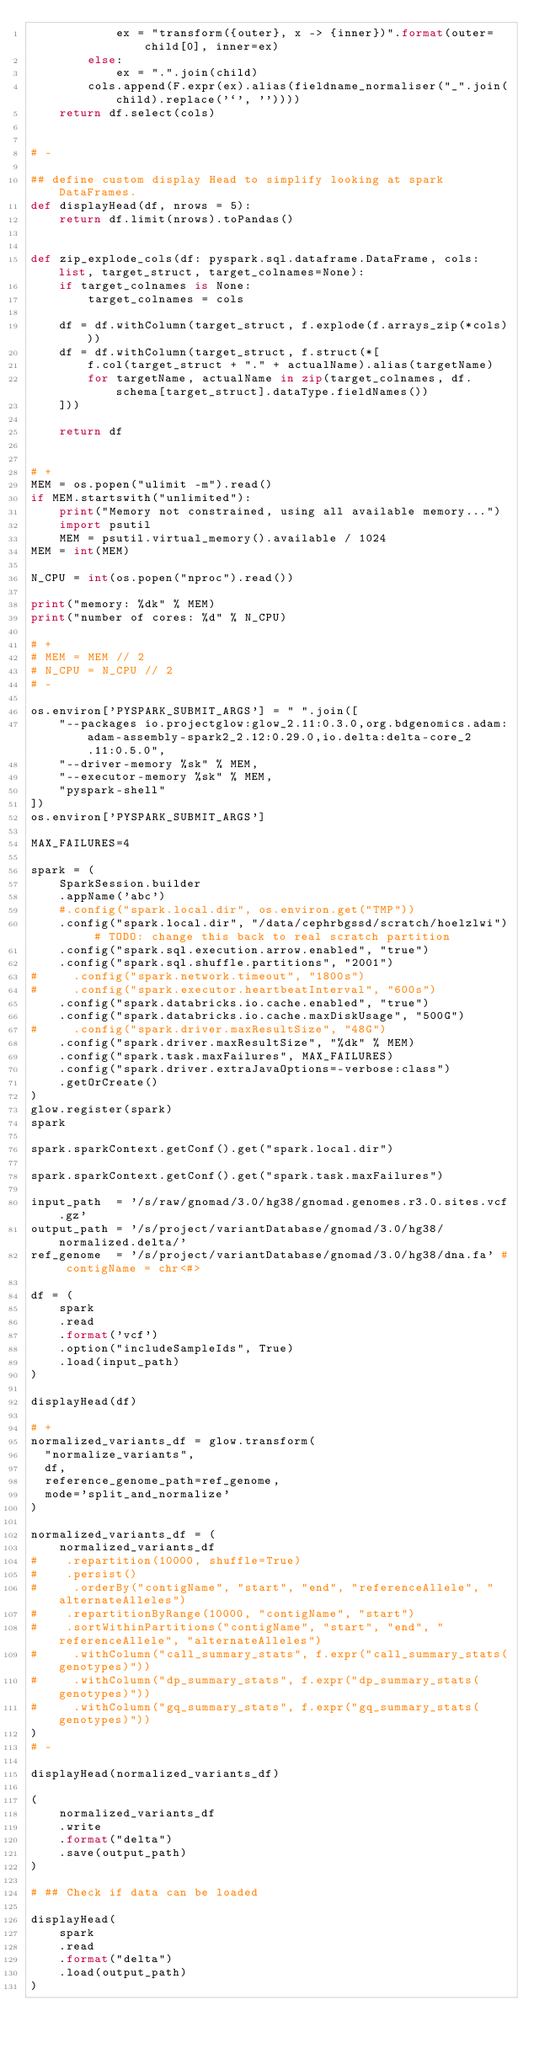Convert code to text. <code><loc_0><loc_0><loc_500><loc_500><_Python_>			ex = "transform({outer}, x -> {inner})".format(outer=child[0], inner=ex)
		else:
			ex = ".".join(child)
		cols.append(F.expr(ex).alias(fieldname_normaliser("_".join(child).replace('`', ''))))
	return df.select(cols)


# -

## define custom display Head to simplify looking at spark DataFrames.
def displayHead(df, nrows = 5):
    return df.limit(nrows).toPandas()


def zip_explode_cols(df: pyspark.sql.dataframe.DataFrame, cols: list, target_struct, target_colnames=None):
    if target_colnames is None:
        target_colnames = cols
    
    df = df.withColumn(target_struct, f.explode(f.arrays_zip(*cols)))
    df = df.withColumn(target_struct, f.struct(*[
        f.col(target_struct + "." + actualName).alias(targetName) 
        for targetName, actualName in zip(target_colnames, df.schema[target_struct].dataType.fieldNames())
    ]))
    
    return df


# +
MEM = os.popen("ulimit -m").read()
if MEM.startswith("unlimited"):
    print("Memory not constrained, using all available memory...")
    import psutil
    MEM = psutil.virtual_memory().available / 1024
MEM = int(MEM)

N_CPU = int(os.popen("nproc").read())

print("memory: %dk" % MEM)
print("number of cores: %d" % N_CPU)

# +
# MEM = MEM // 2
# N_CPU = N_CPU // 2
# -

os.environ['PYSPARK_SUBMIT_ARGS'] = " ".join([
    "--packages io.projectglow:glow_2.11:0.3.0,org.bdgenomics.adam:adam-assembly-spark2_2.12:0.29.0,io.delta:delta-core_2.11:0.5.0",
    "--driver-memory %sk" % MEM,
    "--executor-memory %sk" % MEM,
    "pyspark-shell"
])
os.environ['PYSPARK_SUBMIT_ARGS']

MAX_FAILURES=4

spark = (
    SparkSession.builder
    .appName('abc')
    #.config("spark.local.dir", os.environ.get("TMP"))
    .config("spark.local.dir", "/data/cephrbgssd/scratch/hoelzlwi") # TODO: change this back to real scratch partition
    .config("spark.sql.execution.arrow.enabled", "true")
    .config("spark.sql.shuffle.partitions", "2001")
#     .config("spark.network.timeout", "1800s")
#     .config("spark.executor.heartbeatInterval", "600s")
    .config("spark.databricks.io.cache.enabled", "true")
    .config("spark.databricks.io.cache.maxDiskUsage", "500G")
#     .config("spark.driver.maxResultSize", "48G")
    .config("spark.driver.maxResultSize", "%dk" % MEM)
    .config("spark.task.maxFailures", MAX_FAILURES)
    .config("spark.driver.extraJavaOptions=-verbose:class")
    .getOrCreate()
)
glow.register(spark)
spark

spark.sparkContext.getConf().get("spark.local.dir")

spark.sparkContext.getConf().get("spark.task.maxFailures")

input_path  = '/s/raw/gnomad/3.0/hg38/gnomad.genomes.r3.0.sites.vcf.gz'
output_path = '/s/project/variantDatabase/gnomad/3.0/hg38/normalized.delta/'
ref_genome  = '/s/project/variantDatabase/gnomad/3.0/hg38/dna.fa' # contigName = chr<#>

df = (
    spark
    .read
    .format('vcf')
    .option("includeSampleIds", True)
    .load(input_path)
)

displayHead(df)

# +
normalized_variants_df = glow.transform(
  "normalize_variants",
  df,
  reference_genome_path=ref_genome,
  mode='split_and_normalize'
)

normalized_variants_df = (
    normalized_variants_df
#    .repartition(10000, shuffle=True)
#    .persist()
#     .orderBy("contigName", "start", "end", "referenceAllele", "alternateAlleles")
#    .repartitionByRange(10000, "contigName", "start")
#    .sortWithinPartitions("contigName", "start", "end", "referenceAllele", "alternateAlleles")
#     .withColumn("call_summary_stats", f.expr("call_summary_stats(genotypes)"))
#     .withColumn("dp_summary_stats", f.expr("dp_summary_stats(genotypes)"))
#     .withColumn("gq_summary_stats", f.expr("gq_summary_stats(genotypes)"))
)
# -

displayHead(normalized_variants_df)

(
    normalized_variants_df
    .write
    .format("delta")
    .save(output_path)
)

# ## Check if data can be loaded

displayHead(
    spark
    .read
    .format("delta")
    .load(output_path)
)


</code> 